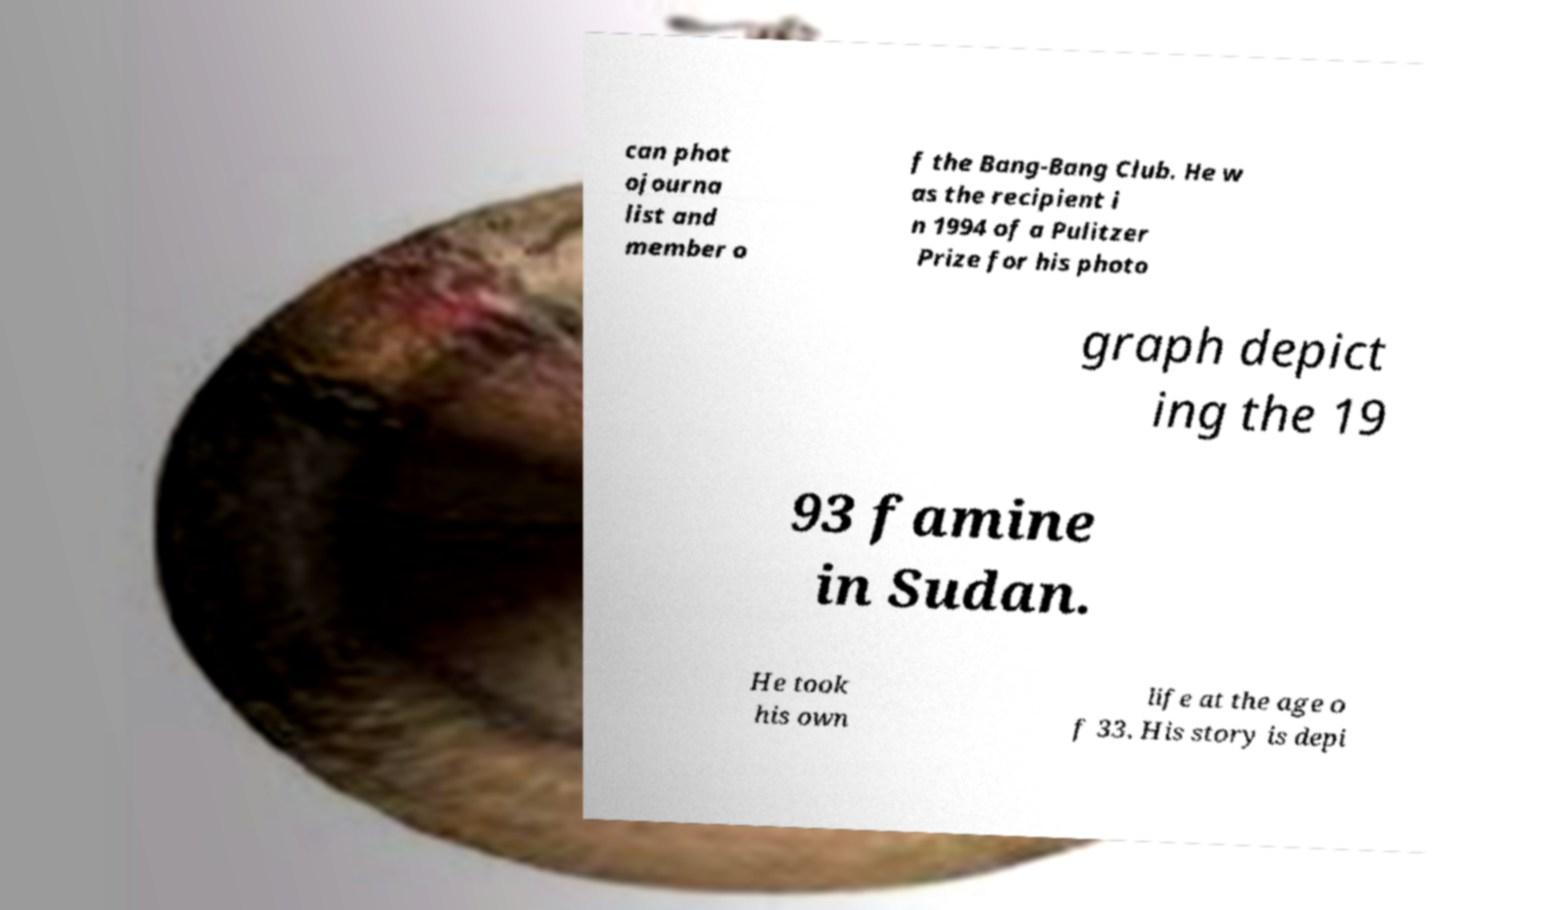There's text embedded in this image that I need extracted. Can you transcribe it verbatim? can phot ojourna list and member o f the Bang-Bang Club. He w as the recipient i n 1994 of a Pulitzer Prize for his photo graph depict ing the 19 93 famine in Sudan. He took his own life at the age o f 33. His story is depi 